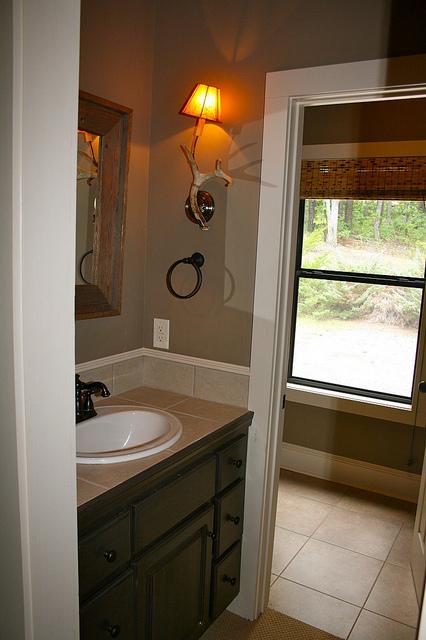Is the window open or closed?
Keep it brief. Closed. What color is the counter?
Write a very short answer. Tan. Is there a house next door?
Answer briefly. No. Is it night time?
Short answer required. No. Is this house vacant?
Quick response, please. Yes. What room is this?
Short answer required. Bathroom. Is the light on?
Write a very short answer. Yes. What material makes up the counter?
Be succinct. Tile. 